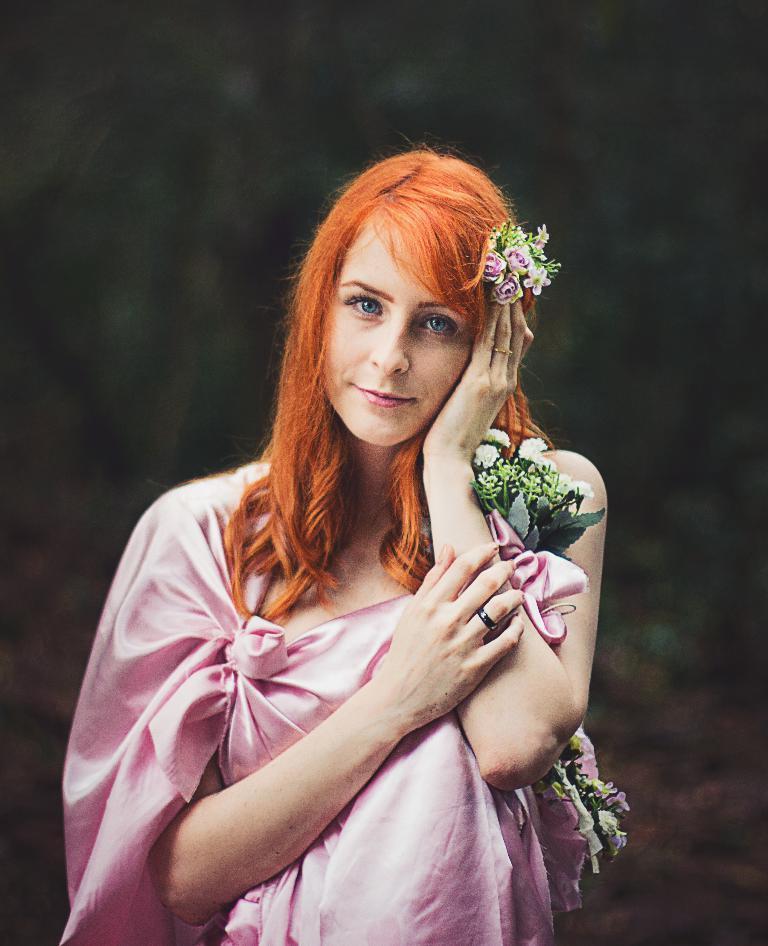Please provide a concise description of this image. In this image there is a woman wearing a pink dress. She is holding few flowers. Background is blurry. 